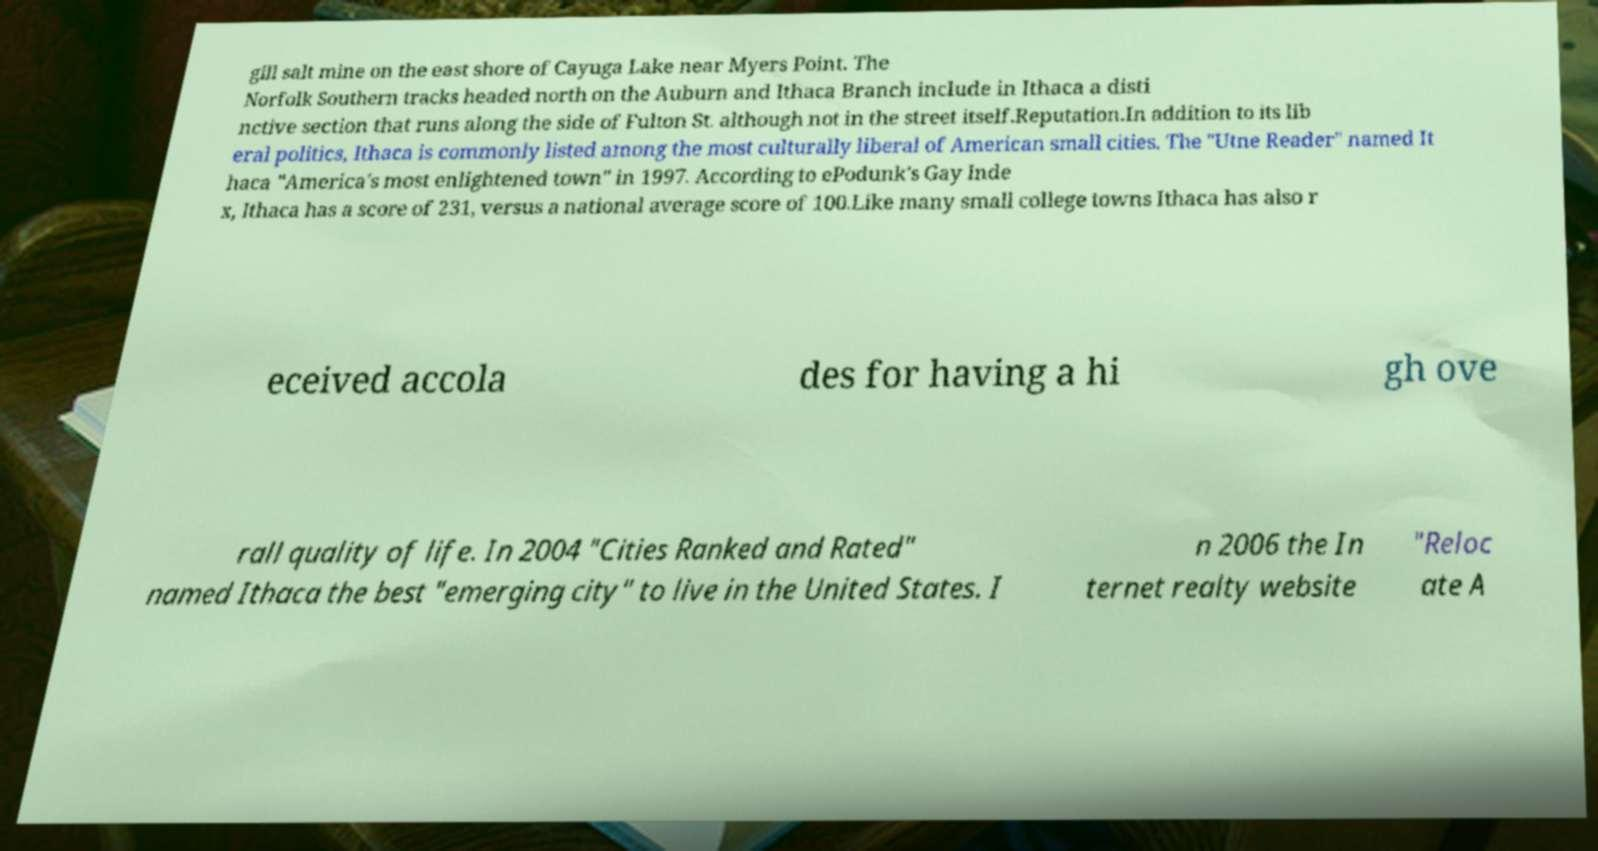There's text embedded in this image that I need extracted. Can you transcribe it verbatim? gill salt mine on the east shore of Cayuga Lake near Myers Point. The Norfolk Southern tracks headed north on the Auburn and Ithaca Branch include in Ithaca a disti nctive section that runs along the side of Fulton St. although not in the street itself.Reputation.In addition to its lib eral politics, Ithaca is commonly listed among the most culturally liberal of American small cities. The "Utne Reader" named It haca "America's most enlightened town" in 1997. According to ePodunk's Gay Inde x, Ithaca has a score of 231, versus a national average score of 100.Like many small college towns Ithaca has also r eceived accola des for having a hi gh ove rall quality of life. In 2004 "Cities Ranked and Rated" named Ithaca the best "emerging city" to live in the United States. I n 2006 the In ternet realty website "Reloc ate A 